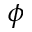Convert formula to latex. <formula><loc_0><loc_0><loc_500><loc_500>\phi</formula> 